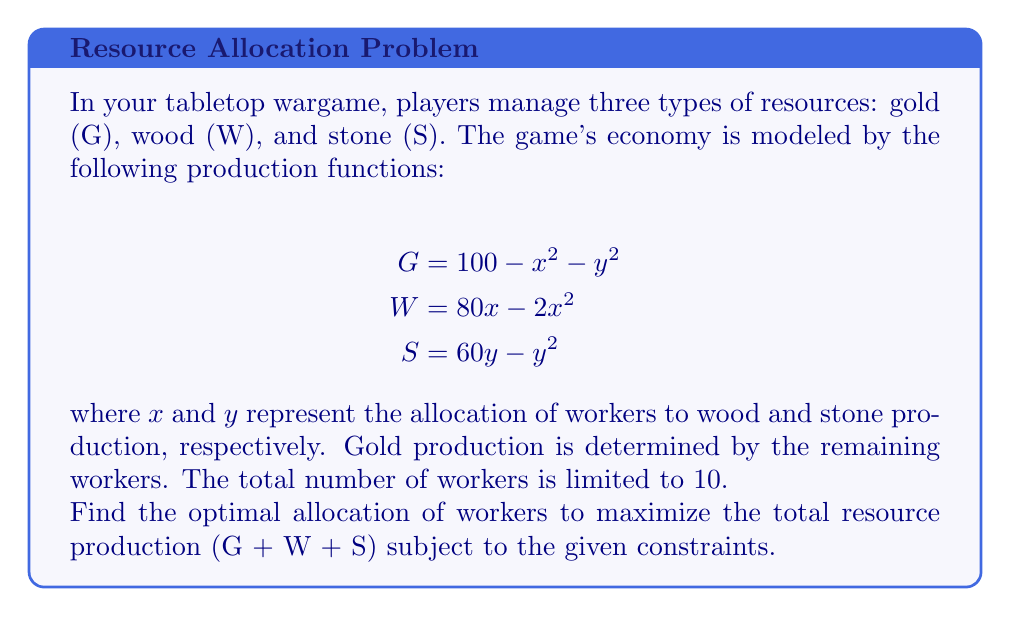Give your solution to this math problem. To solve this constrained optimization problem, we'll use the method of Lagrange multipliers.

1. Define the objective function:
   $$f(x,y) = G + W + S = (100 - x^2 - y^2) + (80x - 2x^2) + (60y - y^2)$$

2. Define the constraint:
   $$g(x,y) = x + y - 10 = 0$$

3. Form the Lagrangian:
   $$L(x,y,\lambda) = f(x,y) - \lambda g(x,y)$$
   $$L(x,y,\lambda) = (100 - x^2 - y^2) + (80x - 2x^2) + (60y - y^2) - \lambda(x + y - 10)$$

4. Calculate partial derivatives and set them to zero:
   $$\frac{\partial L}{\partial x} = -2x + 80 - 4x - \lambda = 0$$
   $$\frac{\partial L}{\partial y} = -2y + 60 - 2y - \lambda = 0$$
   $$\frac{\partial L}{\partial \lambda} = -(x + y - 10) = 0$$

5. Simplify the equations:
   $$-6x + 80 = \lambda$$
   $$-4y + 60 = \lambda$$
   $$x + y = 10$$

6. From the first two equations:
   $$-6x + 80 = -4y + 60$$
   $$-6x + 4y = -20$$
   $$2x = 4y + 20$$
   $$x = 2y + 10$$

7. Substitute into the constraint equation:
   $$(2y + 10) + y = 10$$
   $$3y = 0$$
   $$y = 0$$

8. Solve for x:
   $$x = 2(0) + 10 = 10$$

9. Verify the solution satisfies the constraint:
   $$x + y = 10 + 0 = 10$$

10. Calculate the maximum total resource production:
    $$G = 100 - 10^2 - 0^2 = 0$$
    $$W = 80(10) - 2(10^2) = 600$$
    $$S = 60(0) - 0^2 = 0$$
    $$\text{Total} = G + W + S = 0 + 600 + 0 = 600$$
Answer: The optimal allocation is 10 workers for wood production and 0 workers for stone production, resulting in a maximum total resource production of 600 units. 